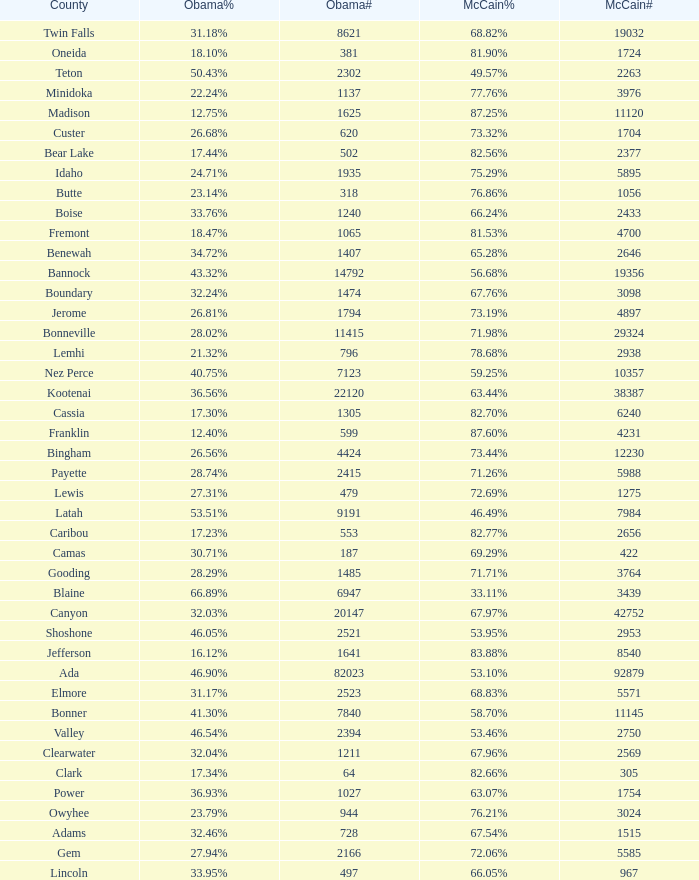What is the maximum McCain population turnout number? 92879.0. 